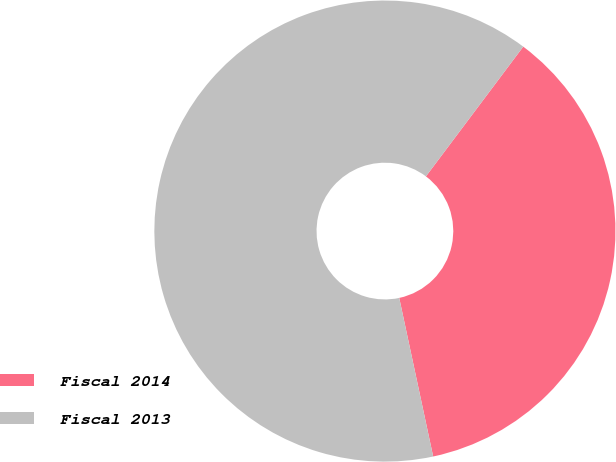<chart> <loc_0><loc_0><loc_500><loc_500><pie_chart><fcel>Fiscal 2014<fcel>Fiscal 2013<nl><fcel>36.4%<fcel>63.6%<nl></chart> 